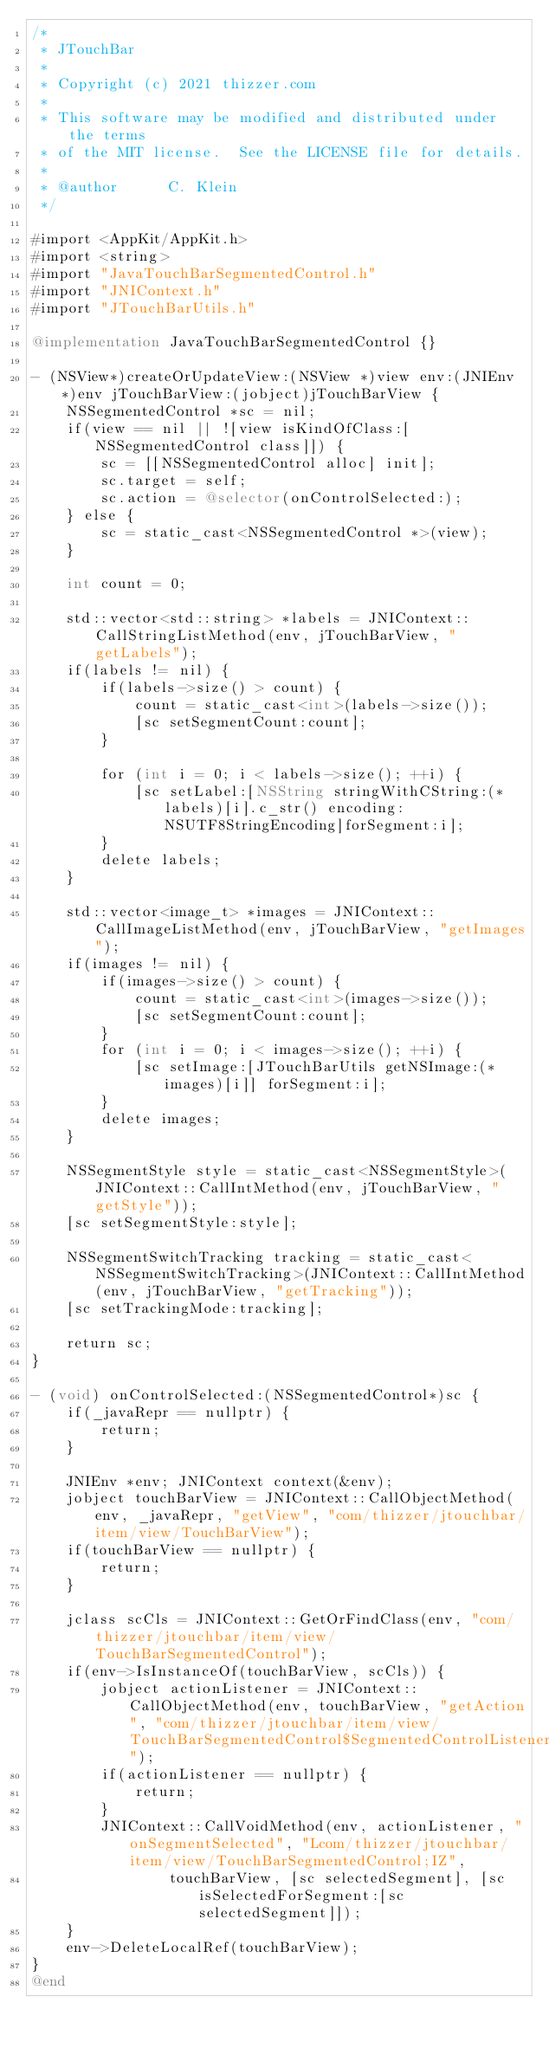Convert code to text. <code><loc_0><loc_0><loc_500><loc_500><_ObjectiveC_>/*
 * JTouchBar
 *
 * Copyright (c) 2021 thizzer.com
 *
 * This software may be modified and distributed under the terms
 * of the MIT license.  See the LICENSE file for details.
 *
 * @author      C. Klein
 */

#import <AppKit/AppKit.h>
#import <string>
#import "JavaTouchBarSegmentedControl.h"
#import "JNIContext.h"
#import "JTouchBarUtils.h"

@implementation JavaTouchBarSegmentedControl {}

- (NSView*)createOrUpdateView:(NSView *)view env:(JNIEnv *)env jTouchBarView:(jobject)jTouchBarView {
    NSSegmentedControl *sc = nil;
    if(view == nil || ![view isKindOfClass:[NSSegmentedControl class]]) {
        sc = [[NSSegmentedControl alloc] init];
        sc.target = self;
        sc.action = @selector(onControlSelected:);
    } else {
        sc = static_cast<NSSegmentedControl *>(view);
    }

    int count = 0;

    std::vector<std::string> *labels = JNIContext::CallStringListMethod(env, jTouchBarView, "getLabels");
    if(labels != nil) {
        if(labels->size() > count) {
            count = static_cast<int>(labels->size());
            [sc setSegmentCount:count];
        }

        for (int i = 0; i < labels->size(); ++i) {
            [sc setLabel:[NSString stringWithCString:(*labels)[i].c_str() encoding:NSUTF8StringEncoding]forSegment:i];
        }
        delete labels;
    }

    std::vector<image_t> *images = JNIContext::CallImageListMethod(env, jTouchBarView, "getImages");
    if(images != nil) {
        if(images->size() > count) {
            count = static_cast<int>(images->size());
            [sc setSegmentCount:count];
        }
        for (int i = 0; i < images->size(); ++i) {
            [sc setImage:[JTouchBarUtils getNSImage:(*images)[i]] forSegment:i];
        }
        delete images;
    }

    NSSegmentStyle style = static_cast<NSSegmentStyle>(JNIContext::CallIntMethod(env, jTouchBarView, "getStyle"));
    [sc setSegmentStyle:style];

    NSSegmentSwitchTracking tracking = static_cast<NSSegmentSwitchTracking>(JNIContext::CallIntMethod(env, jTouchBarView, "getTracking"));
    [sc setTrackingMode:tracking];

    return sc;
}

- (void) onControlSelected:(NSSegmentedControl*)sc {
    if(_javaRepr == nullptr) {
        return;
    }

    JNIEnv *env; JNIContext context(&env);
    jobject touchBarView = JNIContext::CallObjectMethod(env, _javaRepr, "getView", "com/thizzer/jtouchbar/item/view/TouchBarView");
    if(touchBarView == nullptr) {
        return;
    }

    jclass scCls = JNIContext::GetOrFindClass(env, "com/thizzer/jtouchbar/item/view/TouchBarSegmentedControl");
    if(env->IsInstanceOf(touchBarView, scCls)) {
        jobject actionListener = JNIContext::CallObjectMethod(env, touchBarView, "getAction", "com/thizzer/jtouchbar/item/view/TouchBarSegmentedControl$SegmentedControlListener");
        if(actionListener == nullptr) {
            return;
        }
        JNIContext::CallVoidMethod(env, actionListener, "onSegmentSelected", "Lcom/thizzer/jtouchbar/item/view/TouchBarSegmentedControl;IZ",
                touchBarView, [sc selectedSegment], [sc isSelectedForSegment:[sc selectedSegment]]);
    }
    env->DeleteLocalRef(touchBarView);
}
@end</code> 